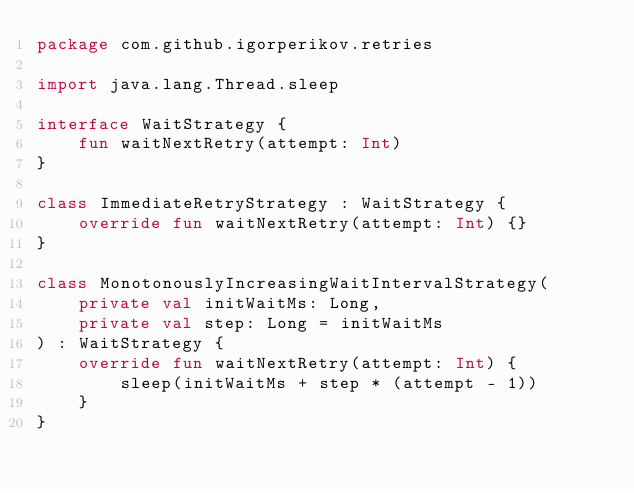<code> <loc_0><loc_0><loc_500><loc_500><_Kotlin_>package com.github.igorperikov.retries

import java.lang.Thread.sleep

interface WaitStrategy {
    fun waitNextRetry(attempt: Int)
}

class ImmediateRetryStrategy : WaitStrategy {
    override fun waitNextRetry(attempt: Int) {}
}

class MonotonouslyIncreasingWaitIntervalStrategy(
    private val initWaitMs: Long,
    private val step: Long = initWaitMs
) : WaitStrategy {
    override fun waitNextRetry(attempt: Int) {
        sleep(initWaitMs + step * (attempt - 1))
    }
}
</code> 